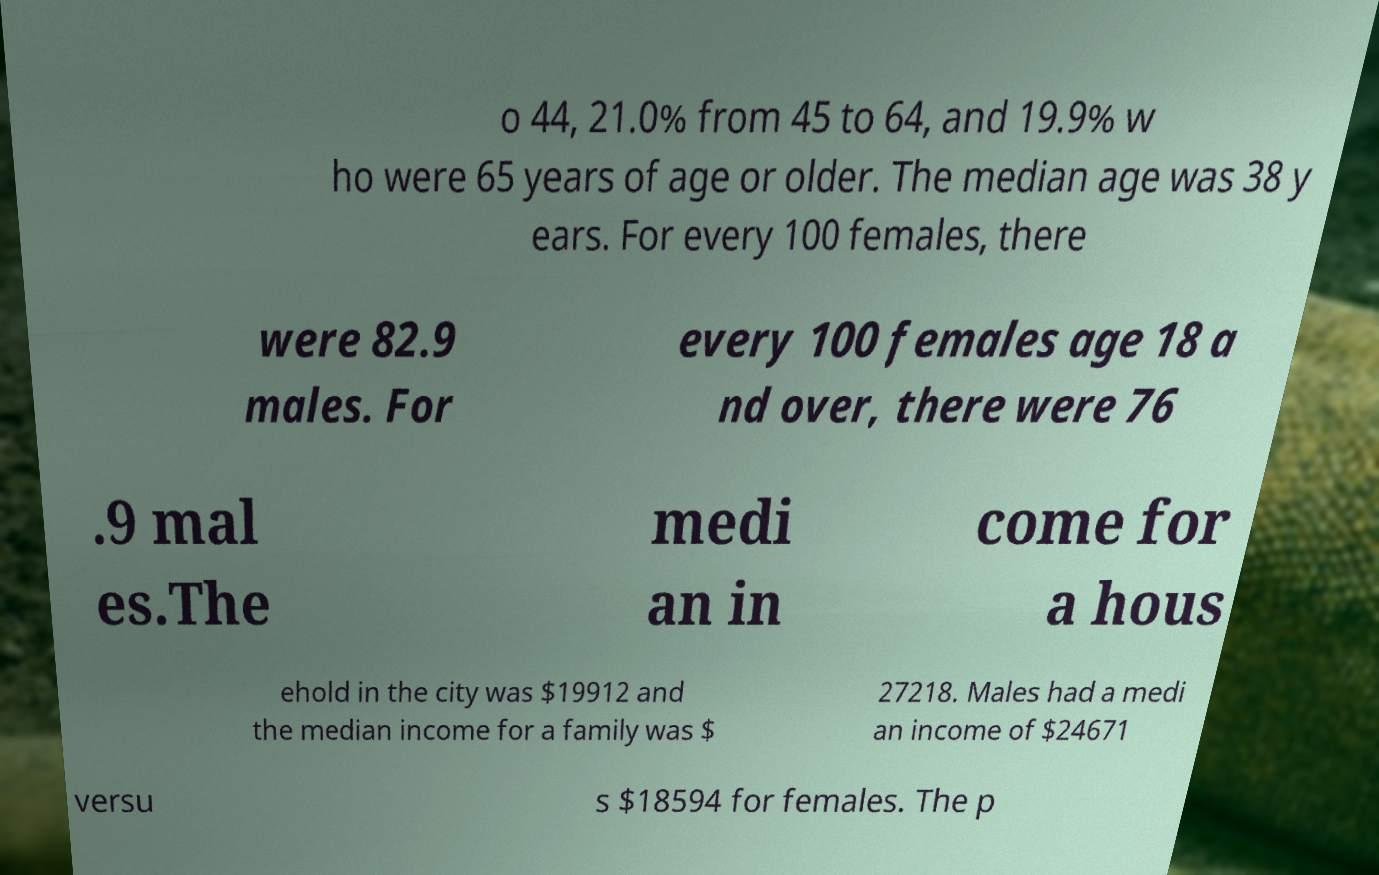Please identify and transcribe the text found in this image. o 44, 21.0% from 45 to 64, and 19.9% w ho were 65 years of age or older. The median age was 38 y ears. For every 100 females, there were 82.9 males. For every 100 females age 18 a nd over, there were 76 .9 mal es.The medi an in come for a hous ehold in the city was $19912 and the median income for a family was $ 27218. Males had a medi an income of $24671 versu s $18594 for females. The p 